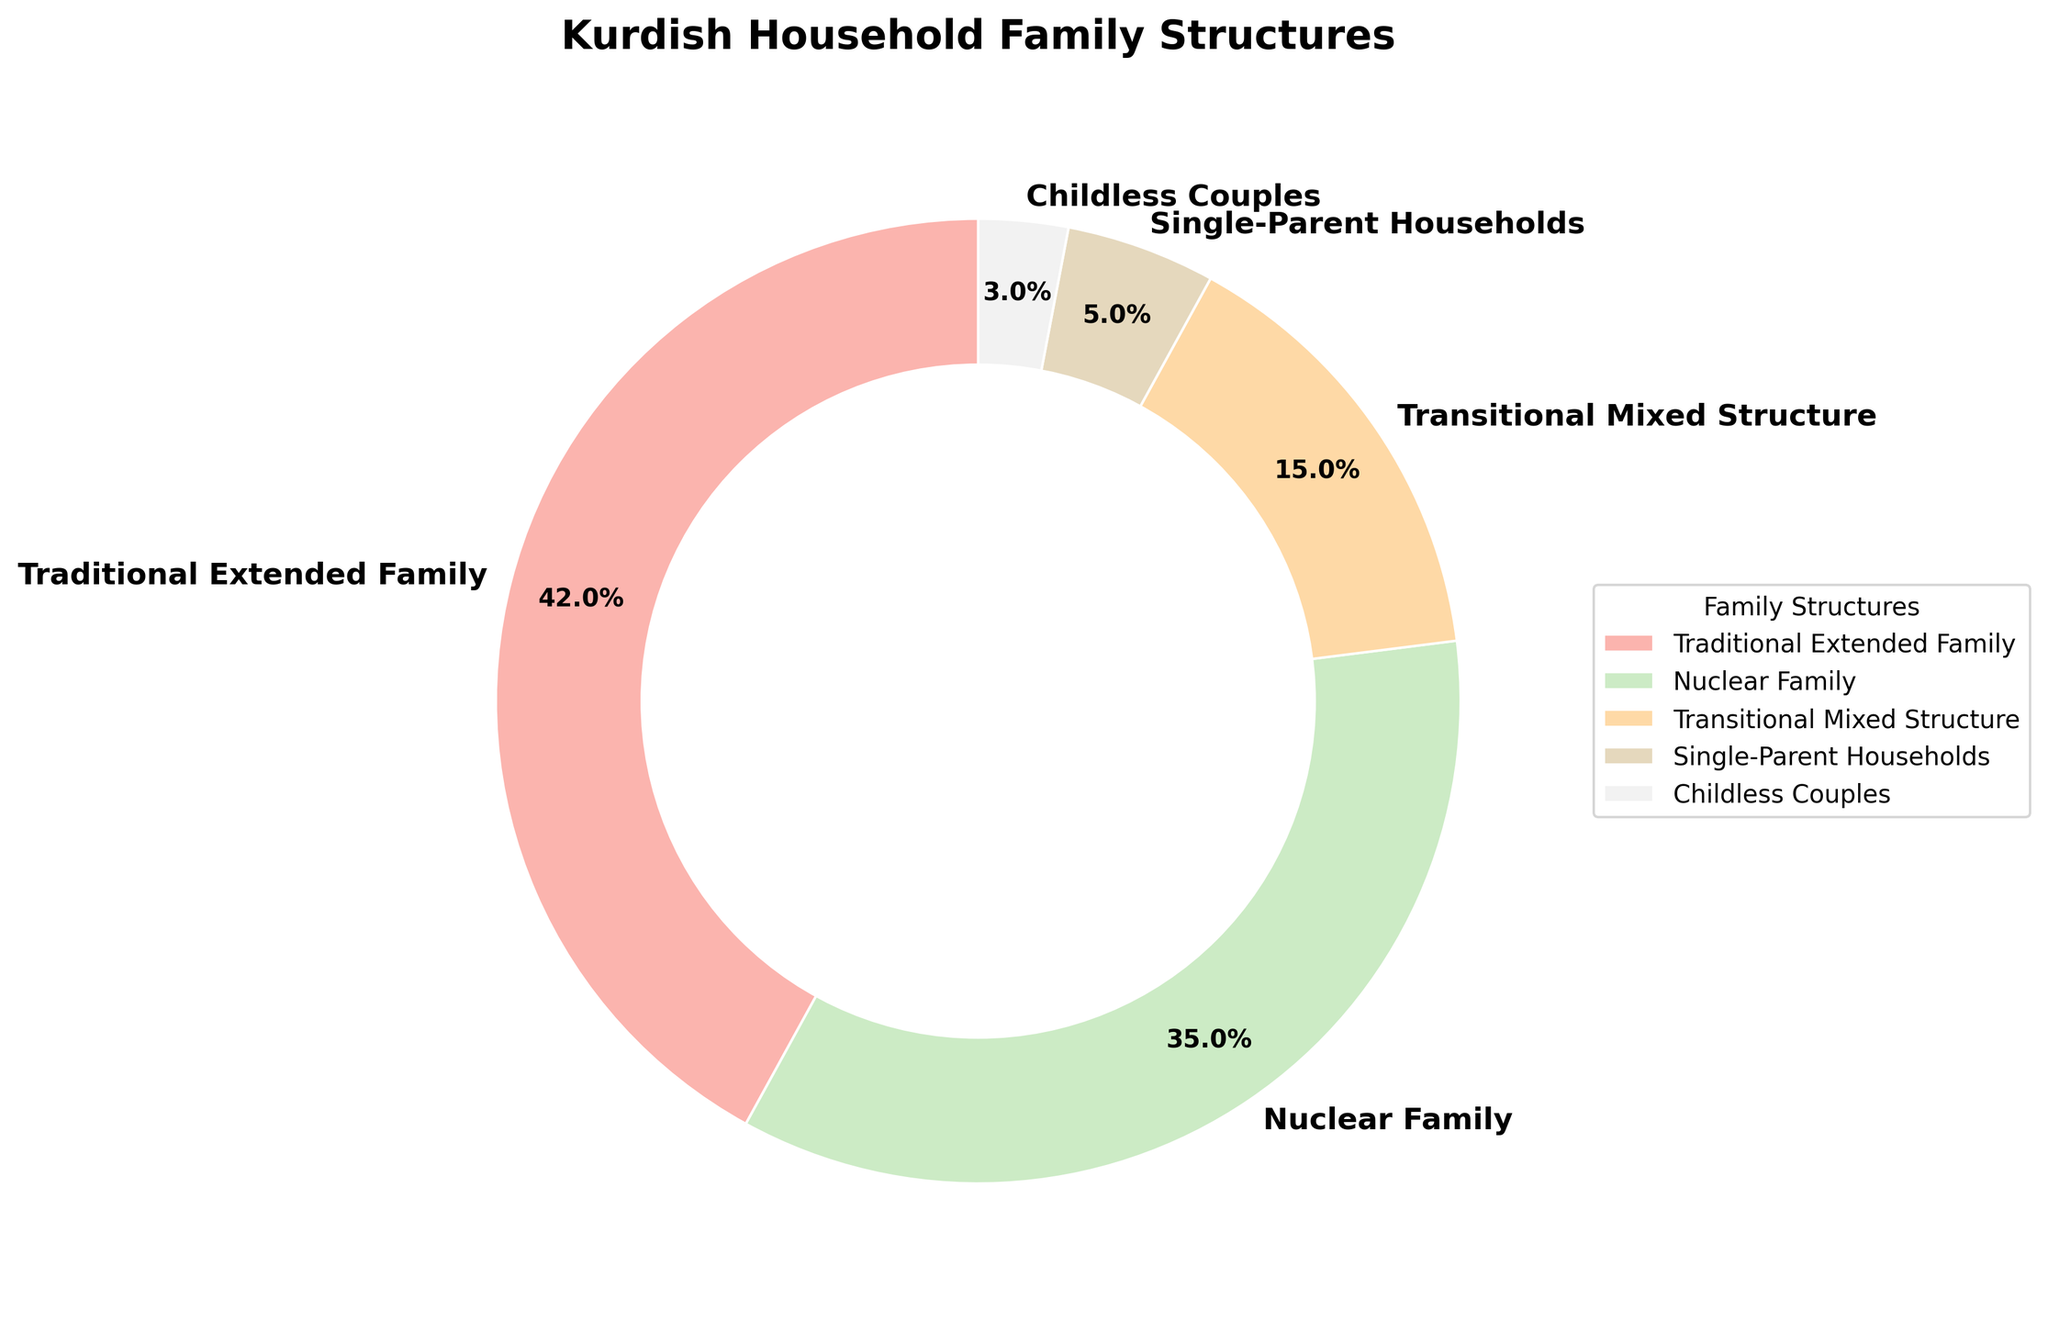What percentage of Kurdish households maintain traditional extended family structures? By looking at the pie chart, the section labeled "Traditional Extended Family" represents 42%. Hence, the percentage of Kurdish households maintaining traditional extended family structures is 42%
Answer: 42% Which family structure is more prevalent: Nuclear Family or Transitional Mixed Structure? By comparing the pie chart sections, the Nuclear Family section is larger (35%) than the Transitional Mixed Structure section (15%). Therefore, the Nuclear Family structure is more prevalent.
Answer: Nuclear Family What is the combined percentage of Kurdish households with single-parent households and childless couples? By adding the percentages of Single-Parent Households (5%) and Childless Couples (3%), we get 5% + 3% = 8%. Thus, the combined percentage is 8%.
Answer: 8% Are there more traditional extended family households or nuclear family households? By comparing the slices for Traditional Extended Family (42%) and Nuclear Family (35%), it is clear that the Traditional Extended Family section is larger. Therefore, there are more Traditional Extended Family households.
Answer: Traditional Extended Family What percentage of Kurdish households do not follow traditional extended or nuclear family models? To find this, sum the percentages of Transitional Mixed Structure (15%), Single-Parent Households (5%), and Childless Couples (3%): 15% + 5% + 3% = 23%. Thus, 23% of households do not follow traditional extended or nuclear family models.
Answer: 23% What is the relative difference in percentage between childless couples and single-parent households? The percentage for Single-Parent Households is 5%, and for Childless Couples, it is 3%. The relative difference is 5% - 3% = 2%. Therefore, the relative difference is 2%.
Answer: 2% Which family structure has the smallest representation, and what is its percentage? Referring to the pie chart, the section labeled "Childless Couples" is the smallest, with a percentage of 3%. Therefore, the smallest representation is Childless Couples at 3%.
Answer: Childless Couples, 3% 